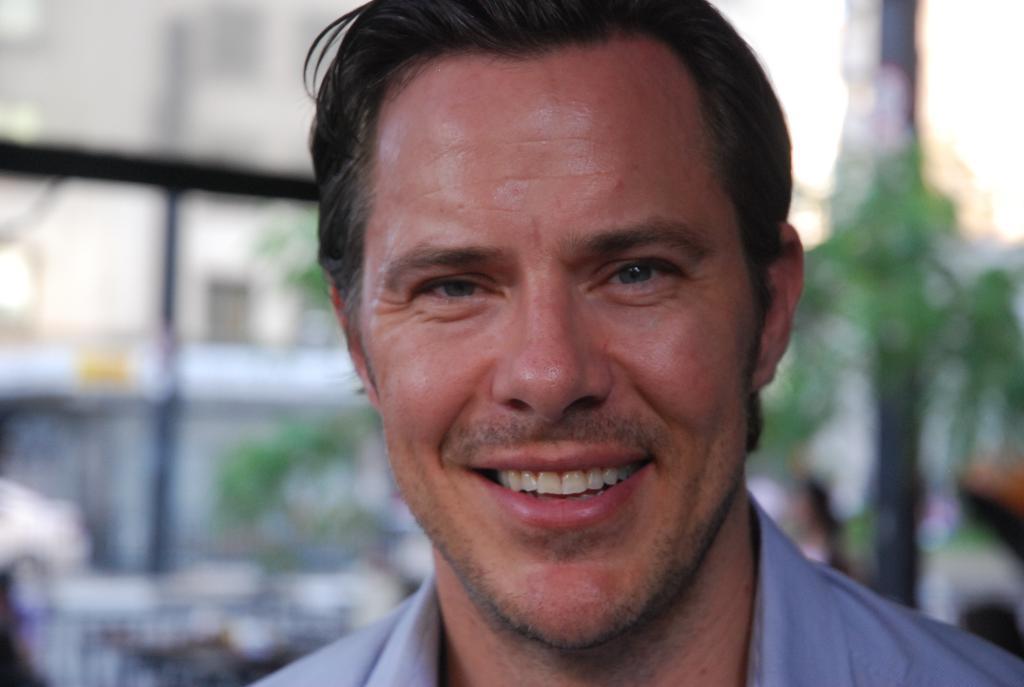Please provide a concise description of this image. In this image we can see a man. In the background we can see sky, trees and an iron grill. 